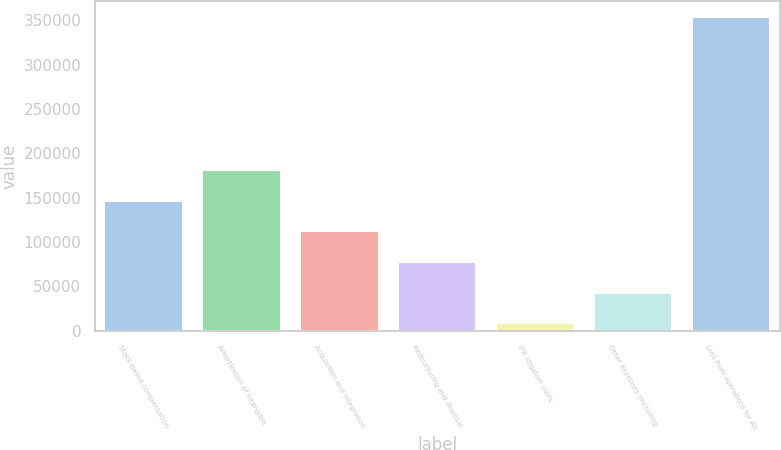Convert chart. <chart><loc_0><loc_0><loc_500><loc_500><bar_chart><fcel>Stock-based compensation<fcel>Amortization of intangible<fcel>Acquisition and integration<fcel>Restructuring and disposal<fcel>IPR litigation costs<fcel>Other expenses (including<fcel>Loss from operations for All<nl><fcel>146629<fcel>181220<fcel>112038<fcel>77446<fcel>8263<fcel>42854.5<fcel>354178<nl></chart> 